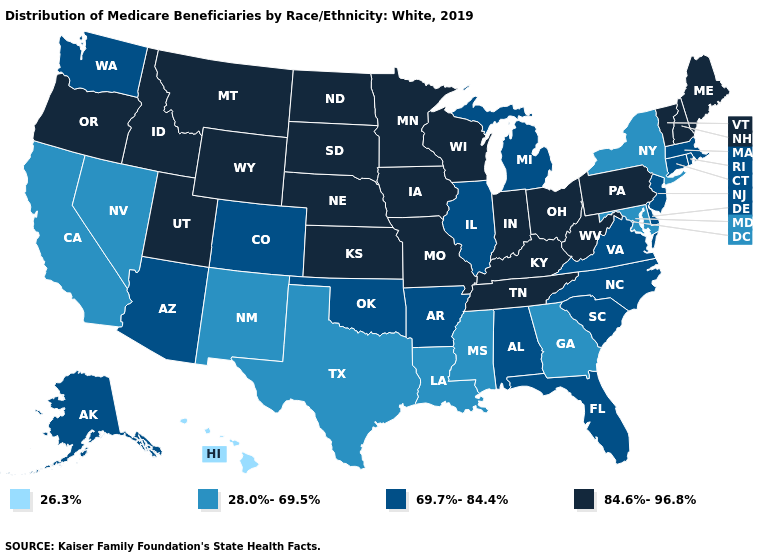Name the states that have a value in the range 26.3%?
Be succinct. Hawaii. Which states have the lowest value in the MidWest?
Short answer required. Illinois, Michigan. Among the states that border Washington , which have the lowest value?
Keep it brief. Idaho, Oregon. Does Maine have the lowest value in the Northeast?
Answer briefly. No. What is the value of New Jersey?
Concise answer only. 69.7%-84.4%. Name the states that have a value in the range 28.0%-69.5%?
Answer briefly. California, Georgia, Louisiana, Maryland, Mississippi, Nevada, New Mexico, New York, Texas. Which states have the highest value in the USA?
Give a very brief answer. Idaho, Indiana, Iowa, Kansas, Kentucky, Maine, Minnesota, Missouri, Montana, Nebraska, New Hampshire, North Dakota, Ohio, Oregon, Pennsylvania, South Dakota, Tennessee, Utah, Vermont, West Virginia, Wisconsin, Wyoming. What is the lowest value in states that border Pennsylvania?
Quick response, please. 28.0%-69.5%. What is the value of South Dakota?
Quick response, please. 84.6%-96.8%. What is the highest value in the USA?
Keep it brief. 84.6%-96.8%. What is the value of Michigan?
Concise answer only. 69.7%-84.4%. What is the value of Texas?
Answer briefly. 28.0%-69.5%. Name the states that have a value in the range 28.0%-69.5%?
Short answer required. California, Georgia, Louisiana, Maryland, Mississippi, Nevada, New Mexico, New York, Texas. Is the legend a continuous bar?
Keep it brief. No. Name the states that have a value in the range 26.3%?
Concise answer only. Hawaii. 